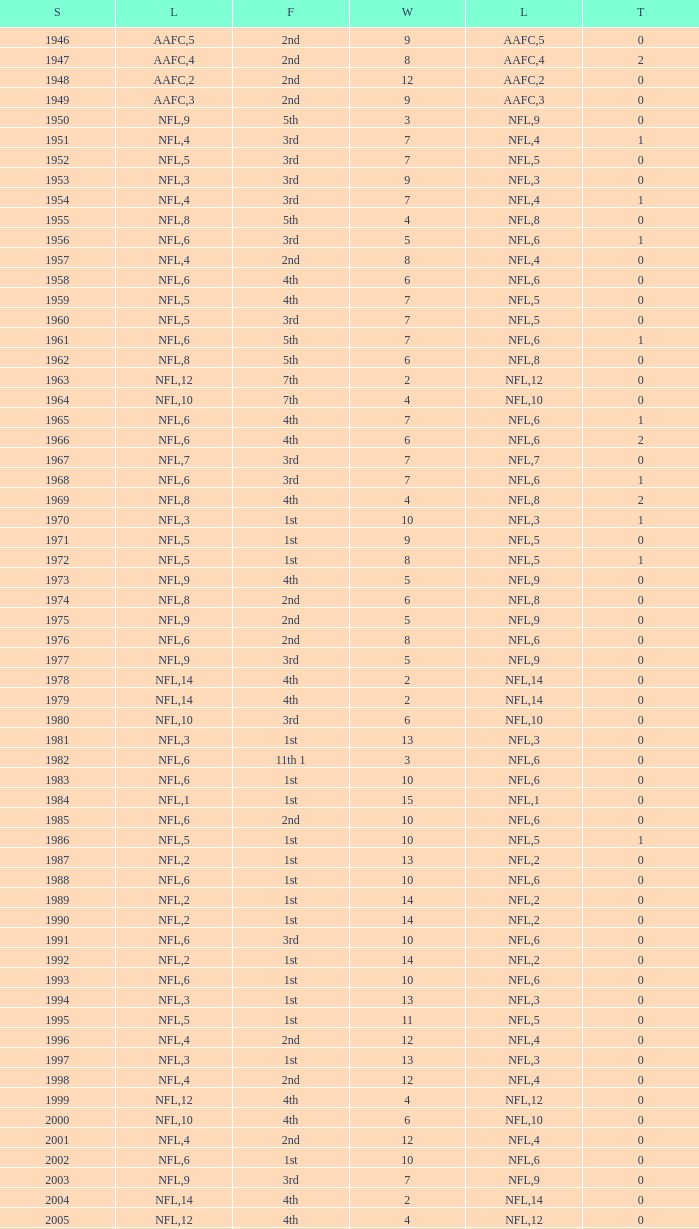What is the highest wins for the NFL with a finish of 1st, and more than 6 losses? None. 